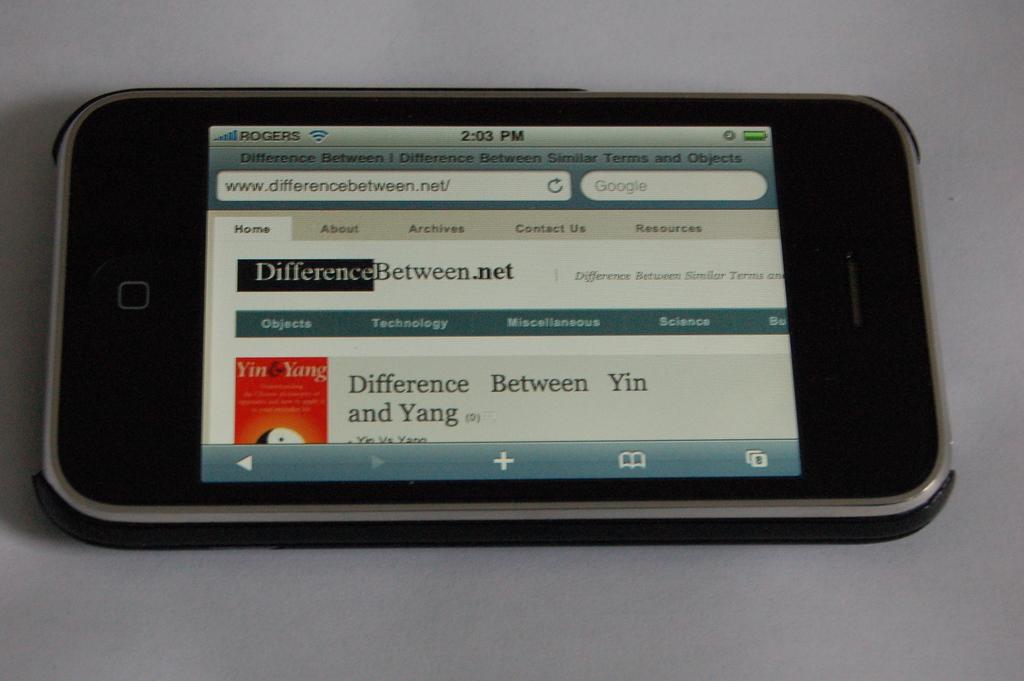What time is displayed on the phone?
Your answer should be compact. 2:03 pm. What is the website the phone is on?
Your answer should be very brief. Differencebetween.net. 